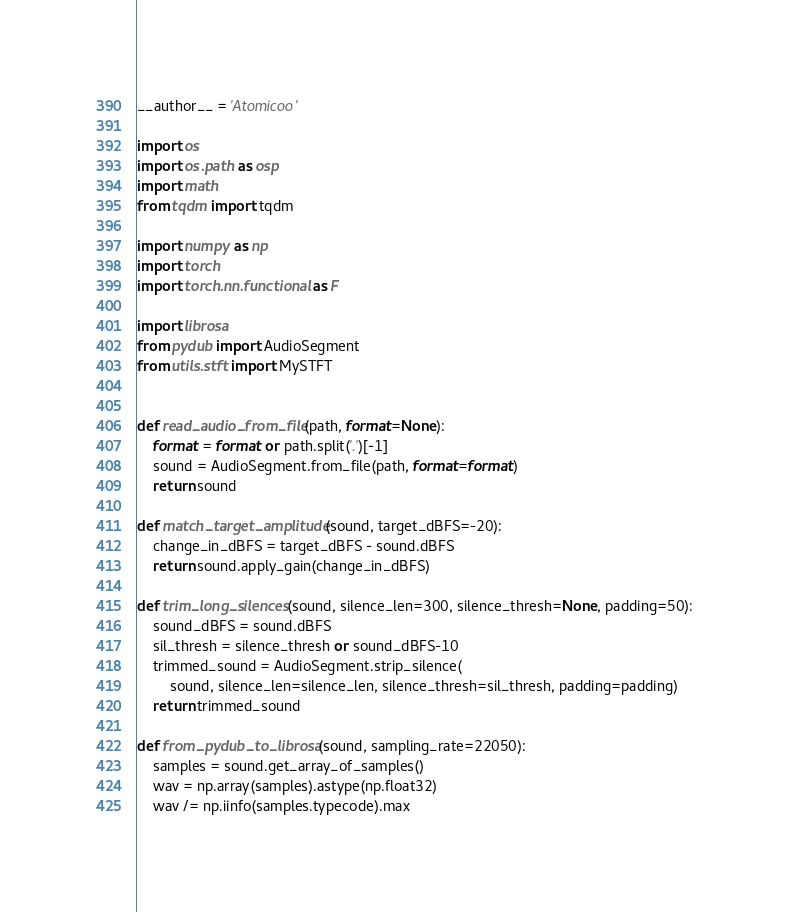Convert code to text. <code><loc_0><loc_0><loc_500><loc_500><_Python_>__author__ = 'Atomicoo'

import os
import os.path as osp
import math
from tqdm import tqdm

import numpy as np
import torch
import torch.nn.functional as F

import librosa
from pydub import AudioSegment
from utils.stft import MySTFT


def read_audio_from_file(path, format=None):
    format = format or path.split('.')[-1]
    sound = AudioSegment.from_file(path, format=format)
    return sound

def match_target_amplitude(sound, target_dBFS=-20):
    change_in_dBFS = target_dBFS - sound.dBFS
    return sound.apply_gain(change_in_dBFS)

def trim_long_silences(sound, silence_len=300, silence_thresh=None, padding=50):
    sound_dBFS = sound.dBFS
    sil_thresh = silence_thresh or sound_dBFS-10
    trimmed_sound = AudioSegment.strip_silence(
        sound, silence_len=silence_len, silence_thresh=sil_thresh, padding=padding)
    return trimmed_sound

def from_pydub_to_librosa(sound, sampling_rate=22050):
    samples = sound.get_array_of_samples()
    wav = np.array(samples).astype(np.float32)
    wav /= np.iinfo(samples.typecode).max</code> 